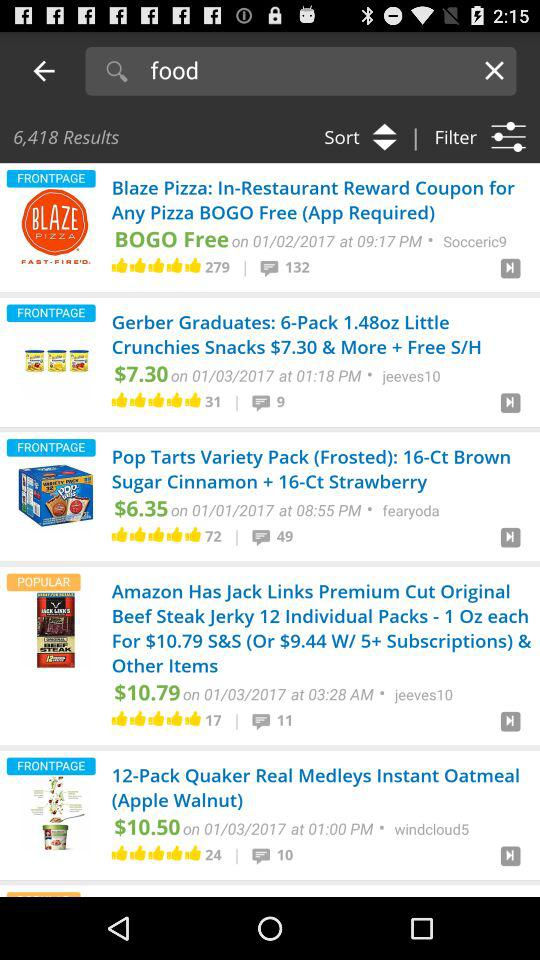When was "Blaze Pizza" posted? "Blaze Pizza" was posted on January 02, 2017 at 09:17 PM. 